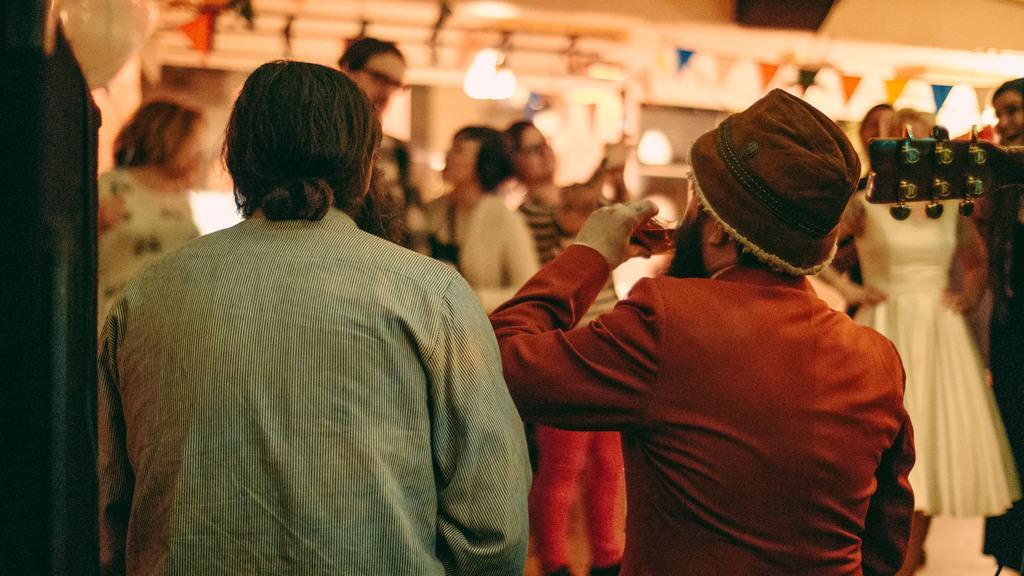Can you describe this image briefly? On the left side, there is a person in a shirt. Beside him, there is another person who is in a brown color shirt. In the background, there are other persons, there are decorative papers attached to a thread and there are lights. And the background is blurred. 